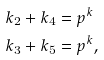<formula> <loc_0><loc_0><loc_500><loc_500>k _ { 2 } + k _ { 4 } & = p ^ { k } \\ k _ { 3 } + k _ { 5 } & = p ^ { k } ,</formula> 